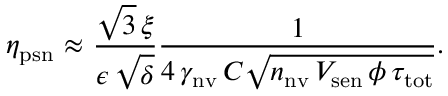Convert formula to latex. <formula><loc_0><loc_0><loc_500><loc_500>\eta _ { p s n } { \approx } \frac { \sqrt { 3 } \, \xi } { \epsilon \, \sqrt { \delta } } \frac { 1 } { 4 \, \gamma _ { n v } \, C \sqrt { n _ { n v } \, V _ { s e n } \, \phi \, \tau _ { t o t } } } .</formula> 